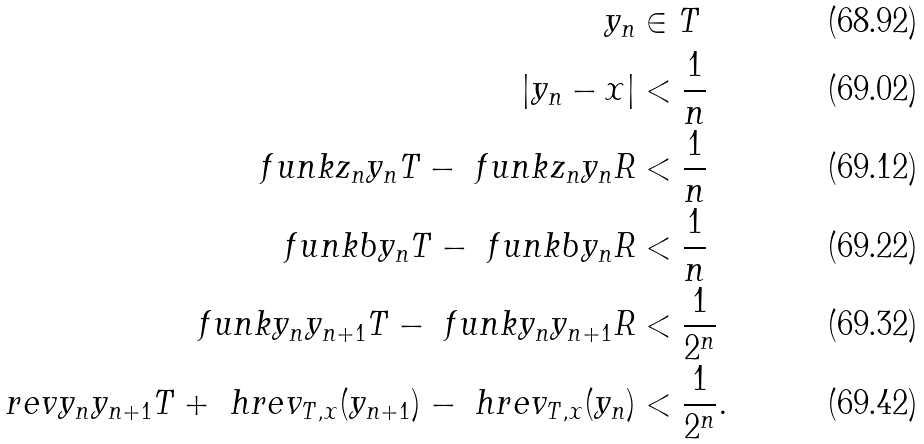Convert formula to latex. <formula><loc_0><loc_0><loc_500><loc_500>y _ { n } & \in T \\ | y _ { n } - x | & < \frac { 1 } { n } \\ \ f u n k { z _ { n } } { y _ { n } } { T } - \ f u n k { z _ { n } } { y _ { n } } { R } & < \frac { 1 } { n } \\ \ f u n k { b } { y _ { n } } { T } - \ f u n k { b } { y _ { n } } { R } & < \frac { 1 } { n } \\ \ f u n k { y _ { n } } { y _ { n + 1 } } { T } - \ f u n k { y _ { n } } { y _ { n + 1 } } { R } & < \frac { 1 } { 2 ^ { n } } \\ \ r e v { y _ { n } } { y _ { n + 1 } } { T } + \ h r e v _ { T , x } ( y _ { n + 1 } ) - \ h r e v _ { T , x } ( y _ { n } ) & < \frac { 1 } { 2 ^ { n } } .</formula> 